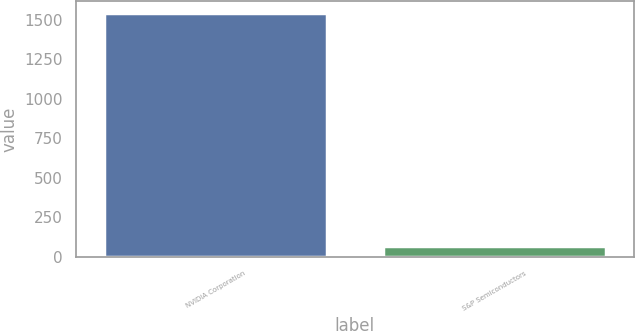Convert chart. <chart><loc_0><loc_0><loc_500><loc_500><bar_chart><fcel>NVIDIA Corporation<fcel>S&P Semiconductors<nl><fcel>1539<fcel>71.41<nl></chart> 